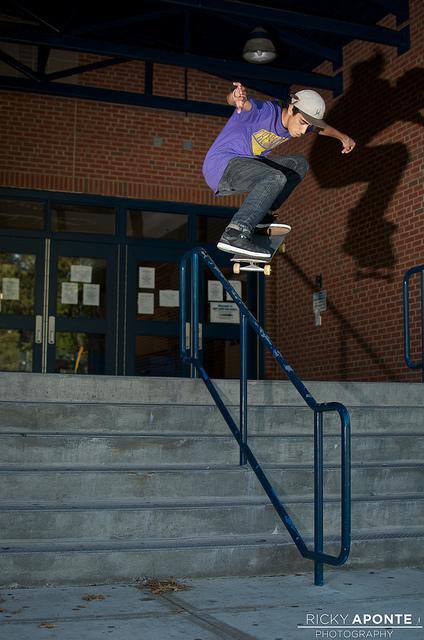How many steps of stairs are there?
Give a very brief answer. 6. How many windows are on the building?
Give a very brief answer. 4. How many steps are there?
Give a very brief answer. 6. How many boys are shown?
Give a very brief answer. 1. 